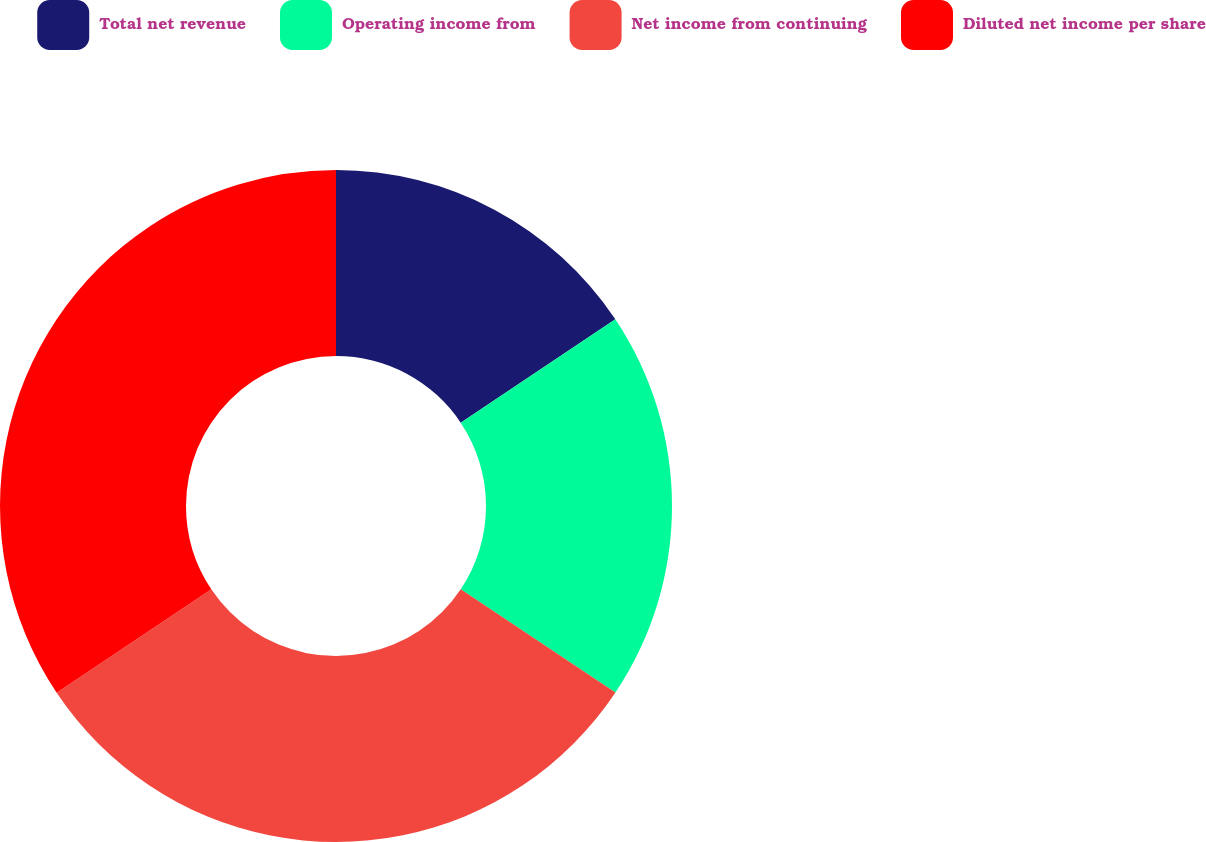Convert chart to OTSL. <chart><loc_0><loc_0><loc_500><loc_500><pie_chart><fcel>Total net revenue<fcel>Operating income from<fcel>Net income from continuing<fcel>Diluted net income per share<nl><fcel>15.62%<fcel>18.75%<fcel>31.25%<fcel>34.38%<nl></chart> 